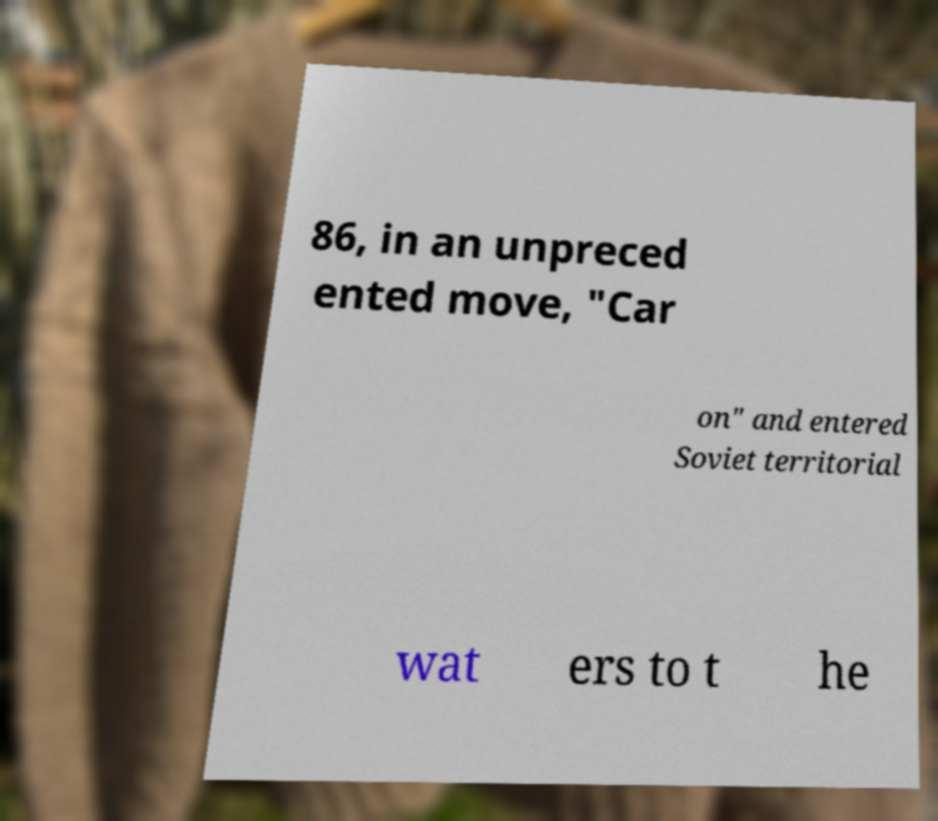I need the written content from this picture converted into text. Can you do that? 86, in an unpreced ented move, "Car on" and entered Soviet territorial wat ers to t he 